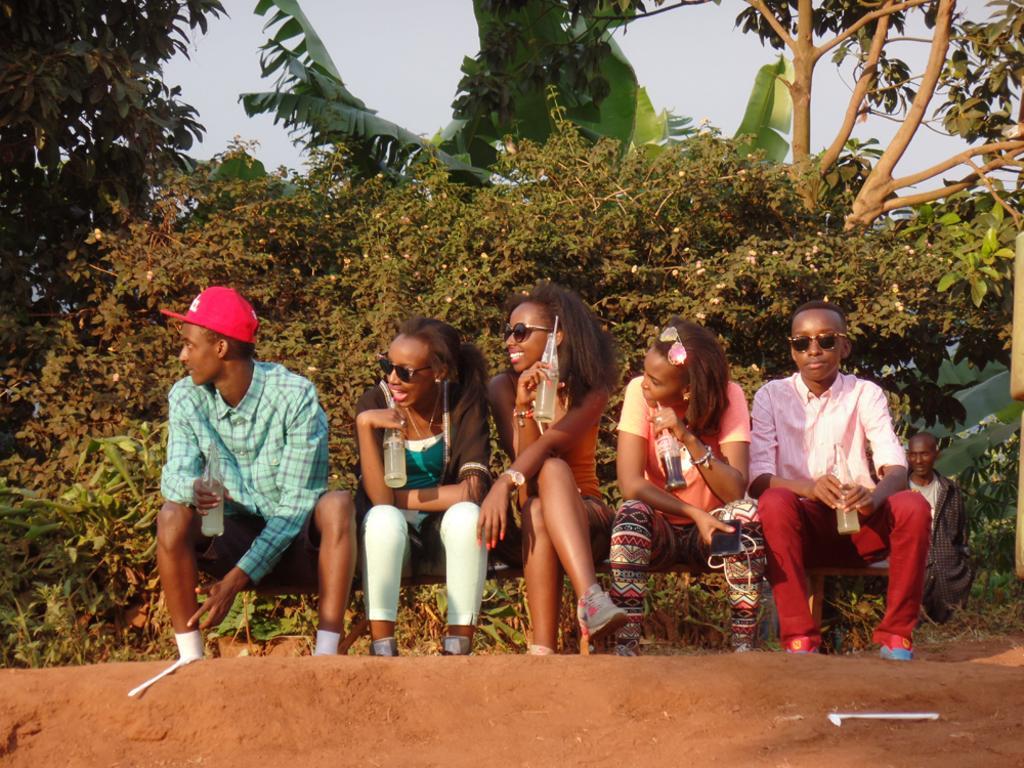Please provide a concise description of this image. In this image we can see group of persons sitting on the surface holding bottles in their hands. In the background, we can see a person standing, group of trees and the sky. 